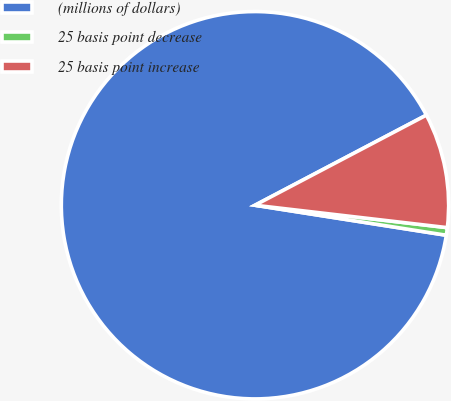<chart> <loc_0><loc_0><loc_500><loc_500><pie_chart><fcel>(millions of dollars)<fcel>25 basis point decrease<fcel>25 basis point increase<nl><fcel>89.82%<fcel>0.63%<fcel>9.55%<nl></chart> 